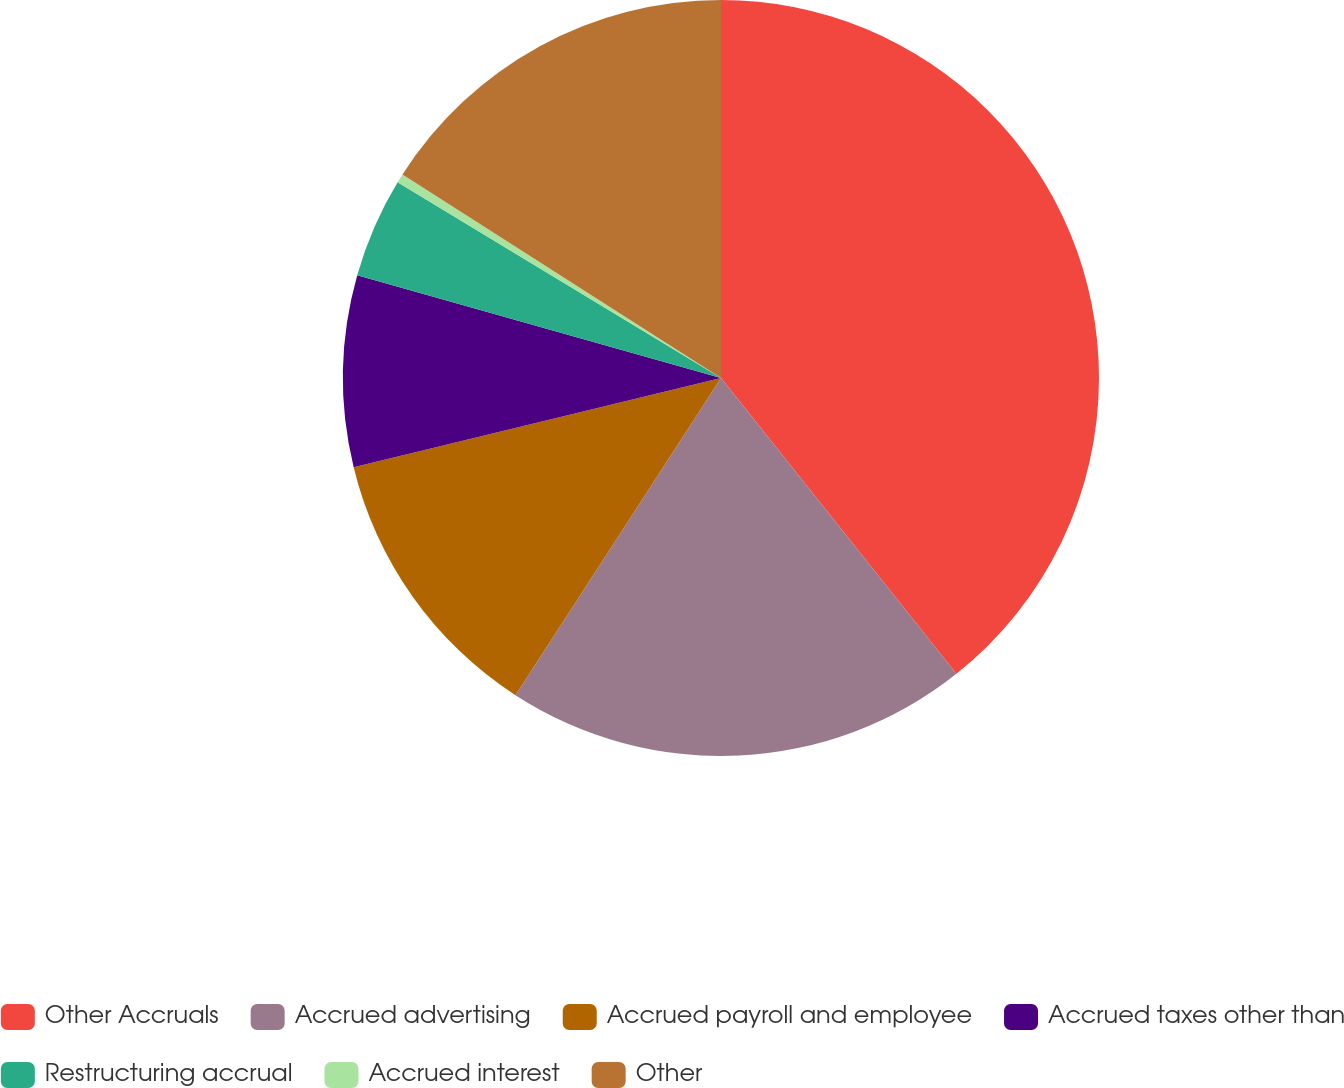<chart> <loc_0><loc_0><loc_500><loc_500><pie_chart><fcel>Other Accruals<fcel>Accrued advertising<fcel>Accrued payroll and employee<fcel>Accrued taxes other than<fcel>Restructuring accrual<fcel>Accrued interest<fcel>Other<nl><fcel>39.3%<fcel>19.85%<fcel>12.06%<fcel>8.17%<fcel>4.28%<fcel>0.39%<fcel>15.95%<nl></chart> 